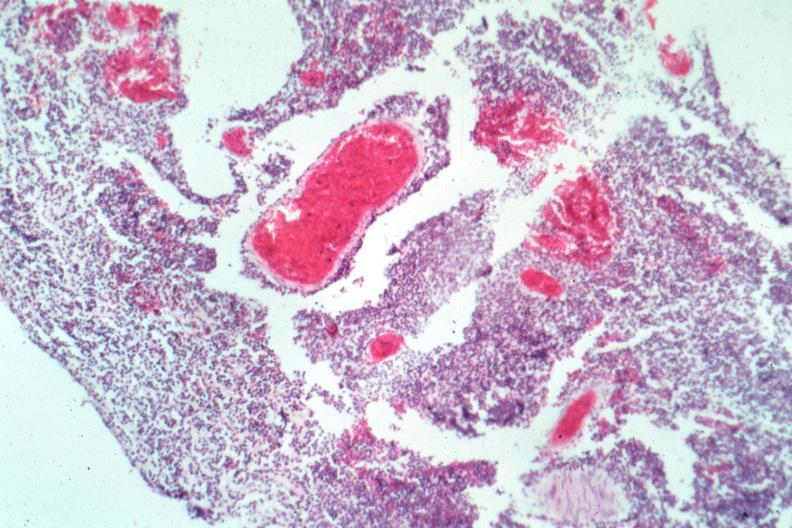s source present?
Answer the question using a single word or phrase. No 